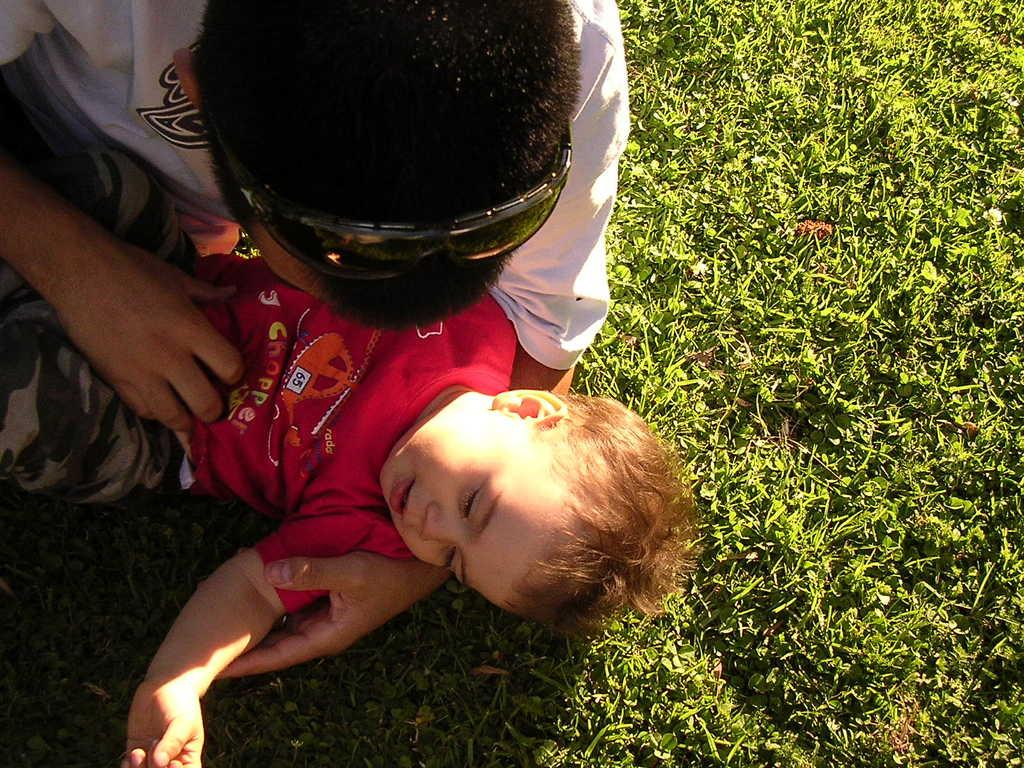What type of accessory is present in the image? There are goggles in the image. How many people are in the image? There are two people in the image. What is the surface on which the two people are standing? The two people are on the grass. What type of dress is the person wearing in the image? There is no dress mentioned in the provided facts, as the focus is on the goggles and the two people. What type of sporting activity is being played in the image? There is no indication of any sporting activity, such as baseball, being played in the image. 